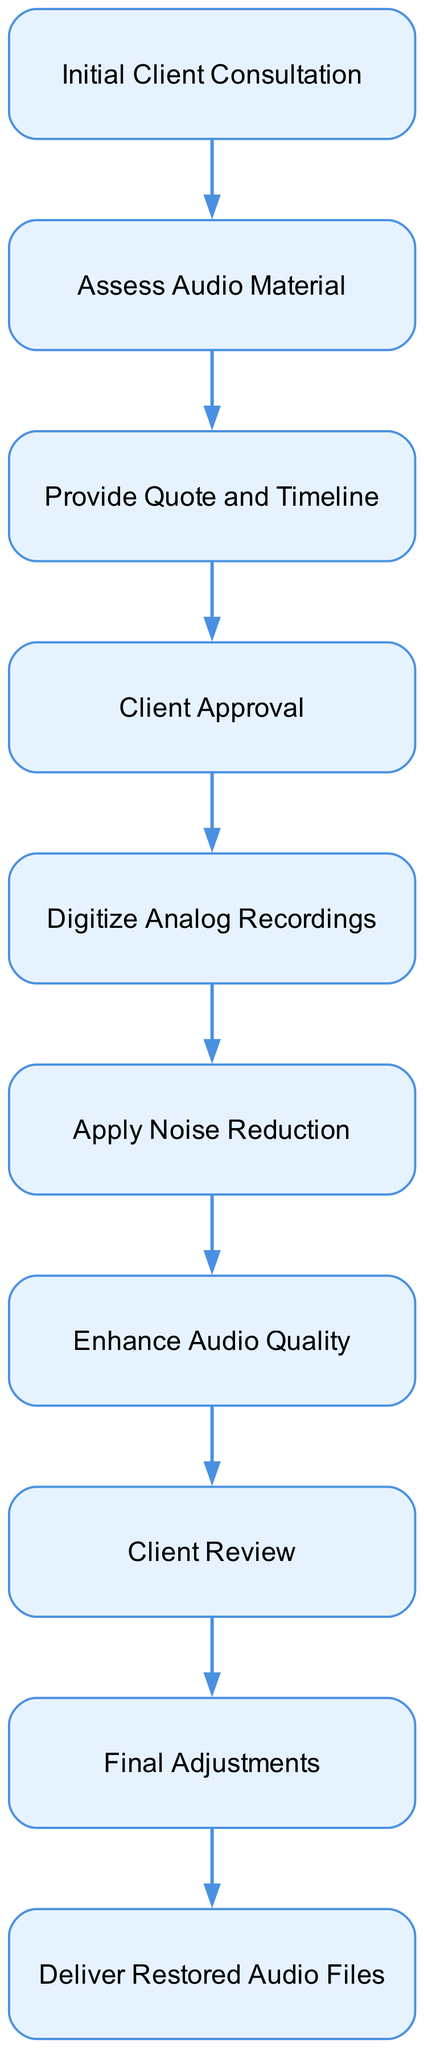What is the first step in the audio restoration process? The first step is indicated by the initial node in the diagram, which is labeled "Initial Client Consultation". This node shows the starting point of the process.
Answer: Initial Client Consultation How many total nodes are present in the diagram? Counting each node listed in the diagram, there are a total of ten nodes representing various stages of the audio restoration process.
Answer: 10 What action follows after the client approval? The action that follows "Client Approval" is represented by the next node connected by an edge, which is "Digitize Analog Recordings". This indicates the progression after the client approves the work.
Answer: Digitize Analog Recordings Which two steps are involved before the client receives the final audio files? The two steps involved are "Final Adjustments" and "Deliver Restored Audio Files", which are adjacent in the flow and show the final part of the restoration process leading to delivery.
Answer: Final Adjustments and Deliver Restored Audio Files What happens after enhancing audio quality? After "Enhance Audio Quality," the next step is "Client Review," where the client assesses the restored audio before any final changes are made. This shows the sequential flow of the project management process.
Answer: Client Review How many edges are there connecting the nodes? By examining the connections between the nodes, there are nine edges that illustrate the progression from the initial consultation to the final delivery step.
Answer: 9 What is the action taken after assessing audio material? The action taken after "Assess Audio Material" is to "Provide Quote and Timeline", indicating the transition from evaluation to service proposal.
Answer: Provide Quote and Timeline What is the last step in the audio restoration process? The last step in the process is represented in the final node labeled "Deliver Restored Audio Files". This confirms the completion of the entire workflow.
Answer: Deliver Restored Audio Files 